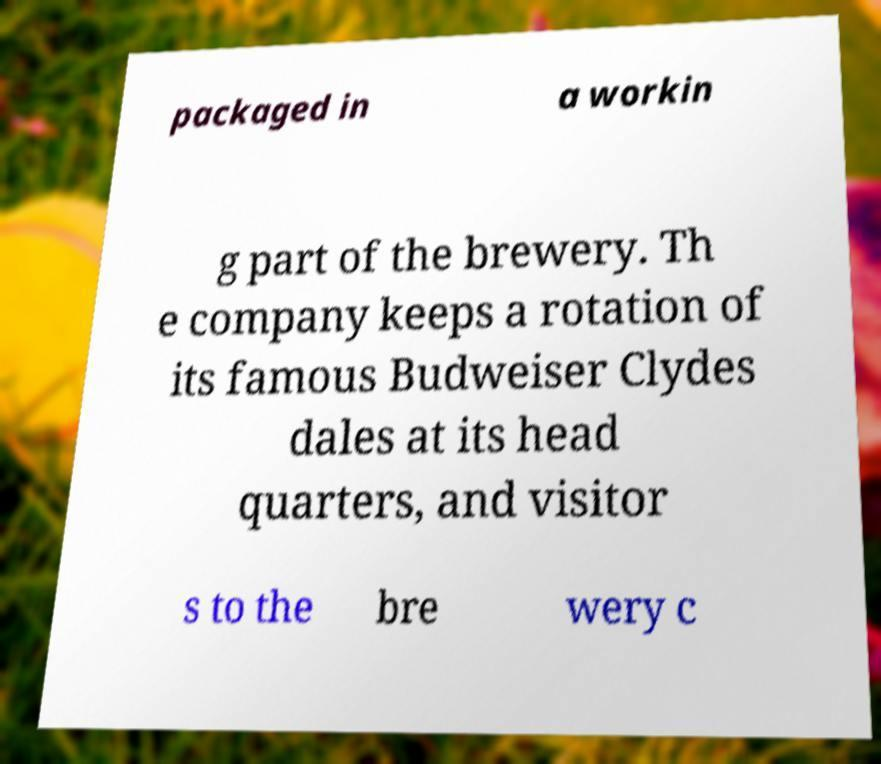Can you accurately transcribe the text from the provided image for me? packaged in a workin g part of the brewery. Th e company keeps a rotation of its famous Budweiser Clydes dales at its head quarters, and visitor s to the bre wery c 